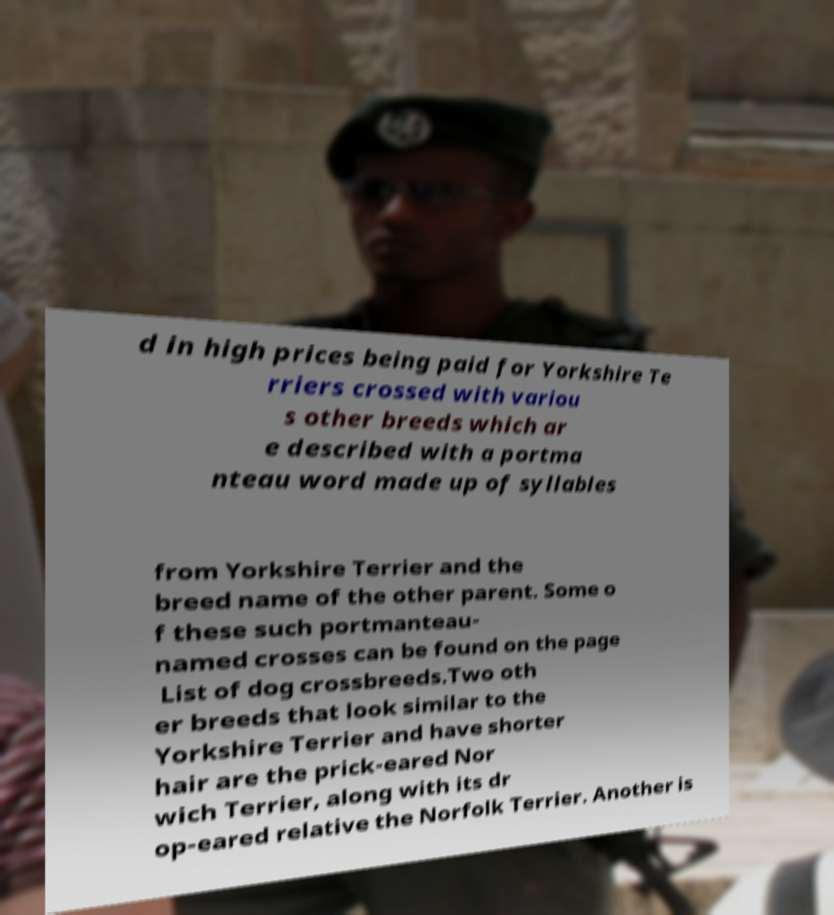Could you extract and type out the text from this image? d in high prices being paid for Yorkshire Te rriers crossed with variou s other breeds which ar e described with a portma nteau word made up of syllables from Yorkshire Terrier and the breed name of the other parent. Some o f these such portmanteau- named crosses can be found on the page List of dog crossbreeds.Two oth er breeds that look similar to the Yorkshire Terrier and have shorter hair are the prick-eared Nor wich Terrier, along with its dr op-eared relative the Norfolk Terrier. Another is 